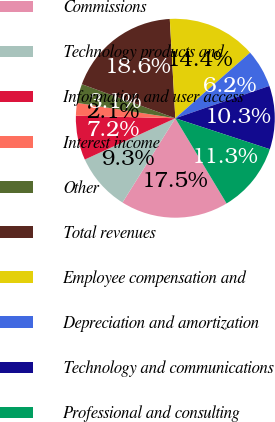Convert chart. <chart><loc_0><loc_0><loc_500><loc_500><pie_chart><fcel>Commissions<fcel>Technology products and<fcel>Information and user access<fcel>Interest income<fcel>Other<fcel>Total revenues<fcel>Employee compensation and<fcel>Depreciation and amortization<fcel>Technology and communications<fcel>Professional and consulting<nl><fcel>17.53%<fcel>9.28%<fcel>7.22%<fcel>2.06%<fcel>3.09%<fcel>18.56%<fcel>14.43%<fcel>6.19%<fcel>10.31%<fcel>11.34%<nl></chart> 